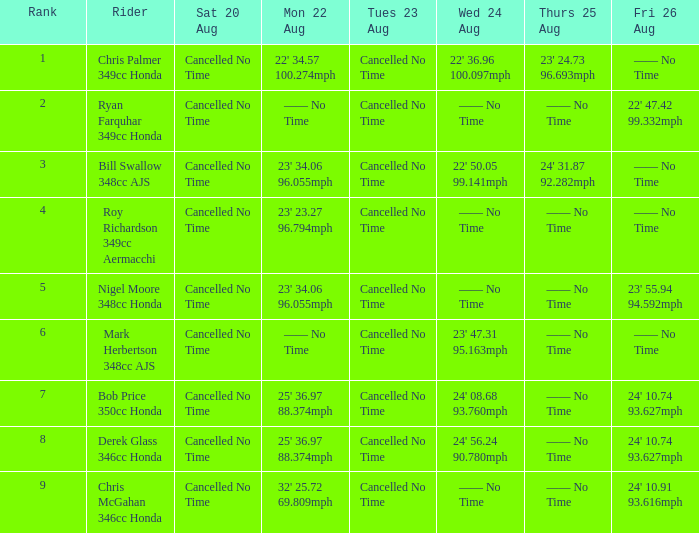If the entry for wednesday, august 24, is 22' 50.05 99.141mph, what are the various entries for monday, august 22? 23' 34.06 96.055mph. 